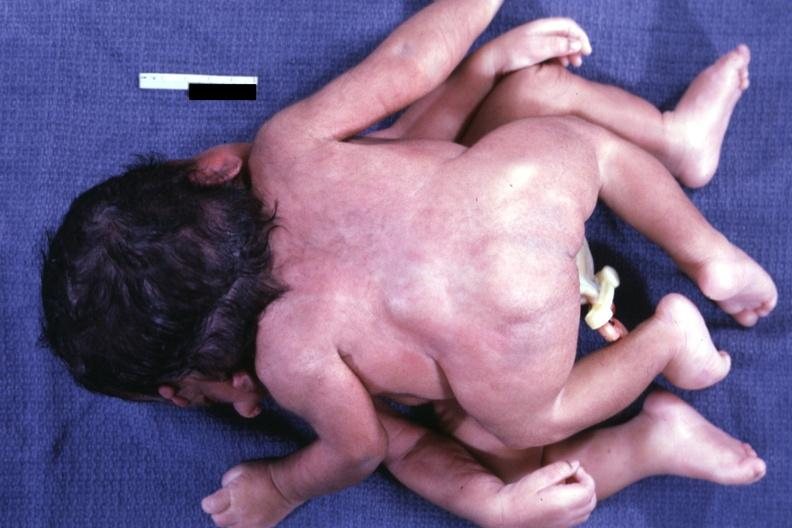s conjoined twins cephalothoracopagus janiceps present?
Answer the question using a single word or phrase. Yes 